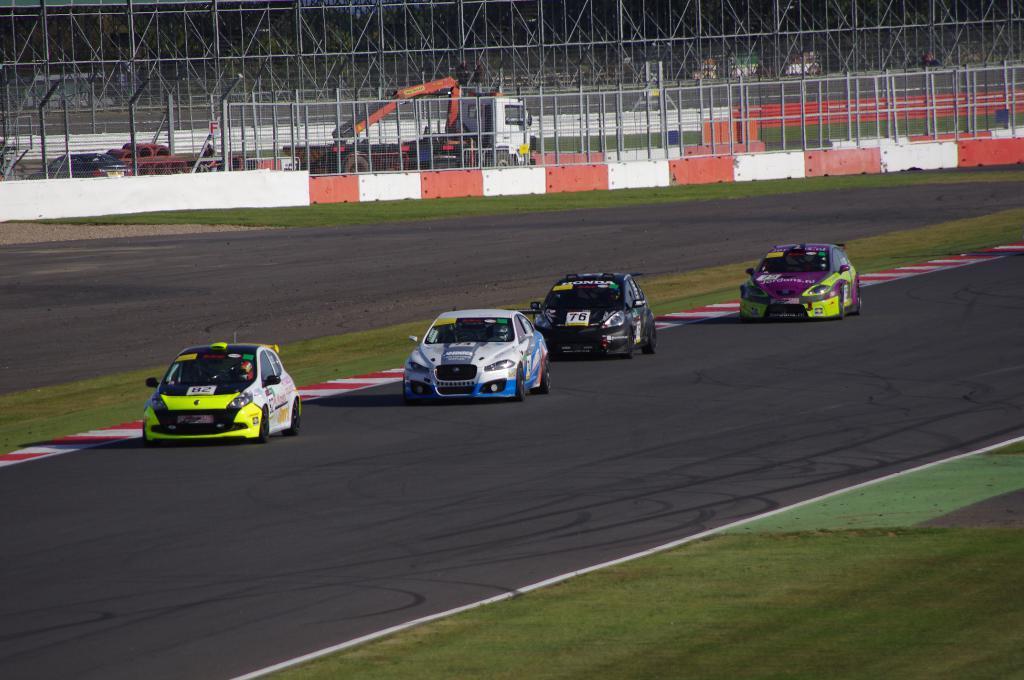Can you describe this image briefly? In the foreground of the picture we can see cars moving on the road. In the center of the picture there are fencing, vehicles, grass and wall. At the top it is fencing. 